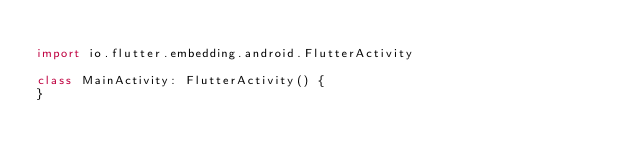<code> <loc_0><loc_0><loc_500><loc_500><_Kotlin_>
import io.flutter.embedding.android.FlutterActivity

class MainActivity: FlutterActivity() {
}
</code> 